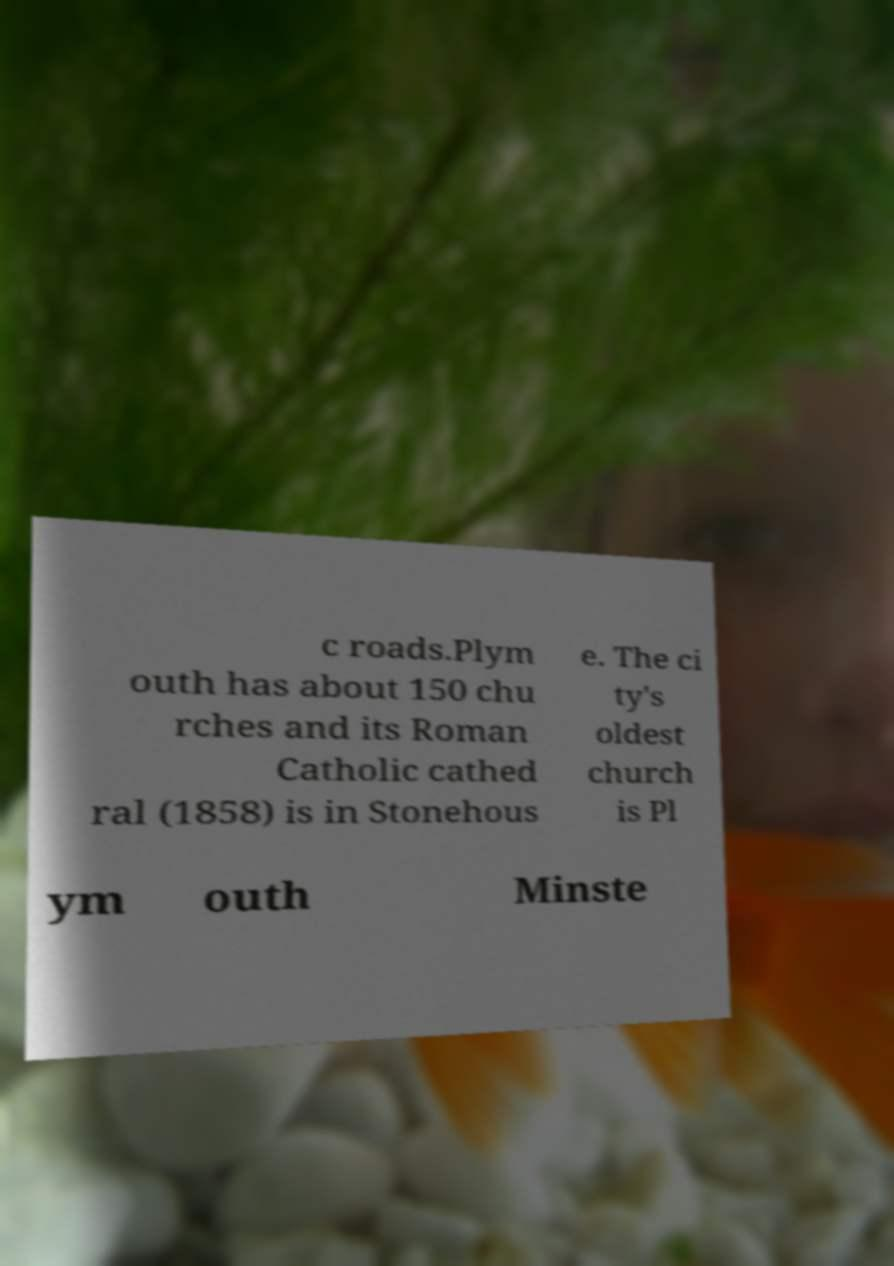I need the written content from this picture converted into text. Can you do that? c roads.Plym outh has about 150 chu rches and its Roman Catholic cathed ral (1858) is in Stonehous e. The ci ty's oldest church is Pl ym outh Minste 